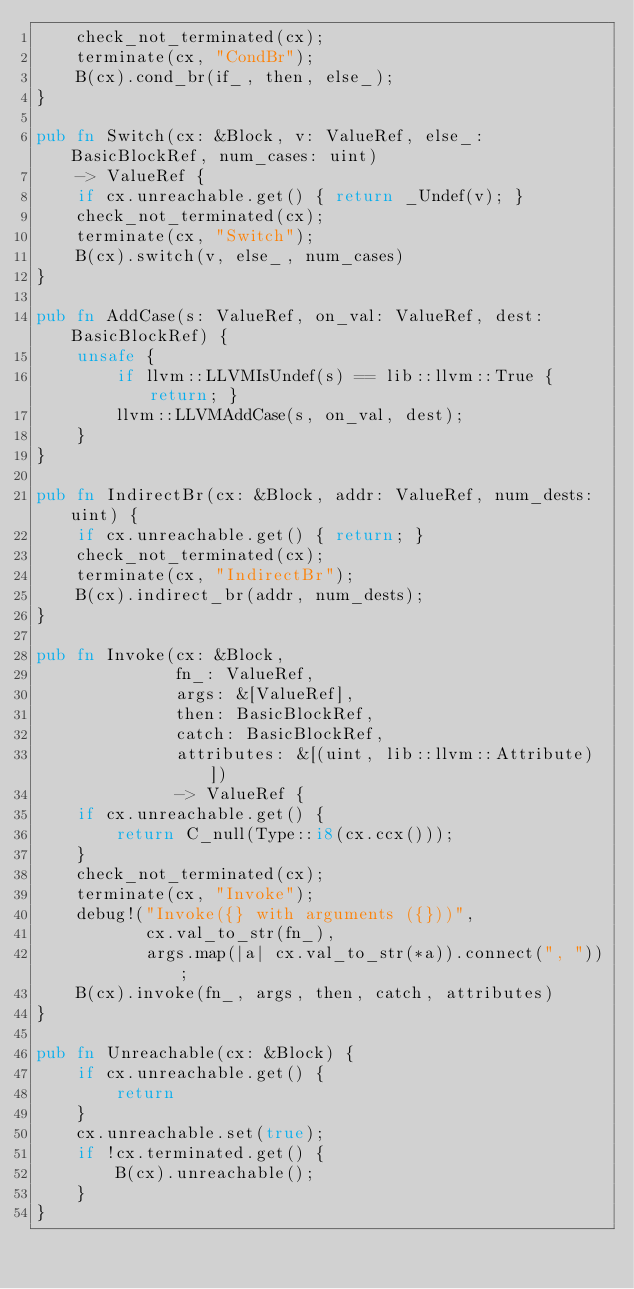<code> <loc_0><loc_0><loc_500><loc_500><_Rust_>    check_not_terminated(cx);
    terminate(cx, "CondBr");
    B(cx).cond_br(if_, then, else_);
}

pub fn Switch(cx: &Block, v: ValueRef, else_: BasicBlockRef, num_cases: uint)
    -> ValueRef {
    if cx.unreachable.get() { return _Undef(v); }
    check_not_terminated(cx);
    terminate(cx, "Switch");
    B(cx).switch(v, else_, num_cases)
}

pub fn AddCase(s: ValueRef, on_val: ValueRef, dest: BasicBlockRef) {
    unsafe {
        if llvm::LLVMIsUndef(s) == lib::llvm::True { return; }
        llvm::LLVMAddCase(s, on_val, dest);
    }
}

pub fn IndirectBr(cx: &Block, addr: ValueRef, num_dests: uint) {
    if cx.unreachable.get() { return; }
    check_not_terminated(cx);
    terminate(cx, "IndirectBr");
    B(cx).indirect_br(addr, num_dests);
}

pub fn Invoke(cx: &Block,
              fn_: ValueRef,
              args: &[ValueRef],
              then: BasicBlockRef,
              catch: BasicBlockRef,
              attributes: &[(uint, lib::llvm::Attribute)])
              -> ValueRef {
    if cx.unreachable.get() {
        return C_null(Type::i8(cx.ccx()));
    }
    check_not_terminated(cx);
    terminate(cx, "Invoke");
    debug!("Invoke({} with arguments ({}))",
           cx.val_to_str(fn_),
           args.map(|a| cx.val_to_str(*a)).connect(", "));
    B(cx).invoke(fn_, args, then, catch, attributes)
}

pub fn Unreachable(cx: &Block) {
    if cx.unreachable.get() {
        return
    }
    cx.unreachable.set(true);
    if !cx.terminated.get() {
        B(cx).unreachable();
    }
}
</code> 